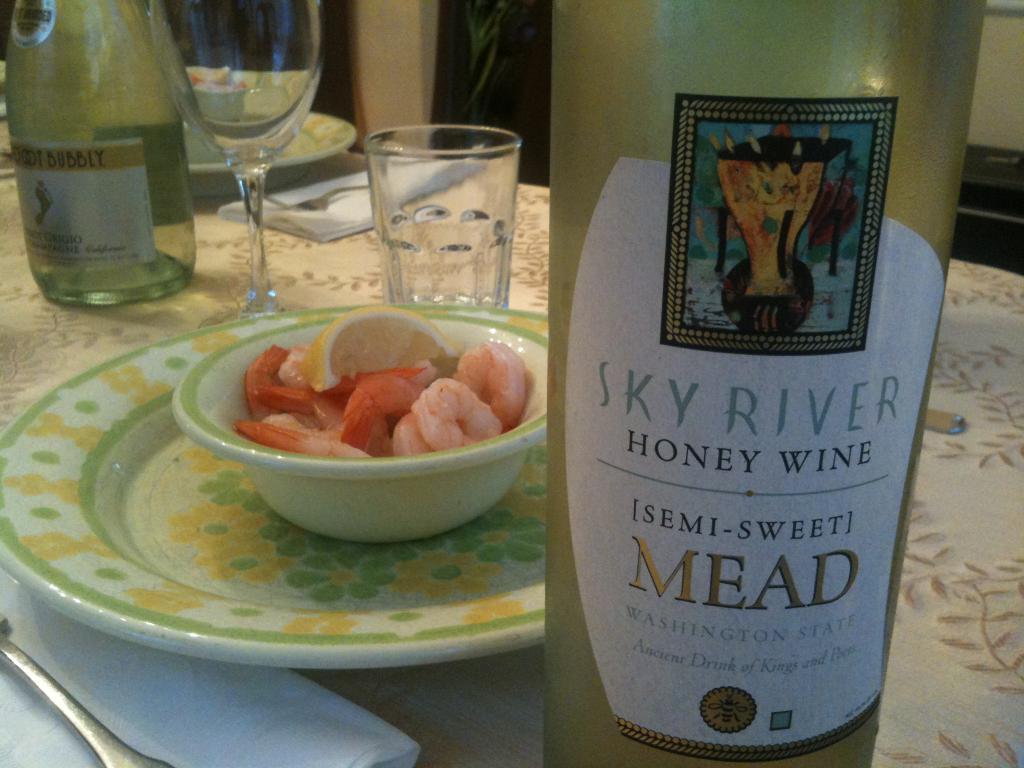What is the brand of this drink?
Keep it short and to the point. Sky river. 